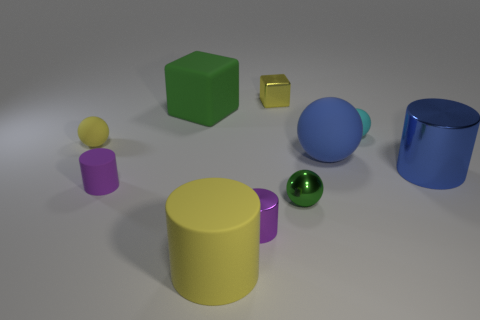There is a tiny yellow thing left of the big green cube; is its shape the same as the big yellow thing?
Give a very brief answer. No. What is the material of the small yellow sphere?
Offer a very short reply. Rubber. What shape is the purple thing behind the small purple object that is to the right of the green thing left of the yellow metal thing?
Your answer should be compact. Cylinder. What number of other things are there of the same shape as the big yellow rubber object?
Your answer should be compact. 3. There is a metal block; is its color the same as the cylinder on the right side of the tiny yellow shiny thing?
Your response must be concise. No. What number of green matte balls are there?
Provide a succinct answer. 0. What number of things are tiny yellow metallic objects or cyan objects?
Offer a very short reply. 2. There is a matte sphere that is the same color as the big shiny object; what is its size?
Your answer should be compact. Large. There is a large green matte object; are there any big things in front of it?
Your answer should be compact. Yes. Are there more small yellow blocks that are behind the small yellow block than tiny yellow metallic cubes that are to the right of the cyan ball?
Your answer should be very brief. No. 